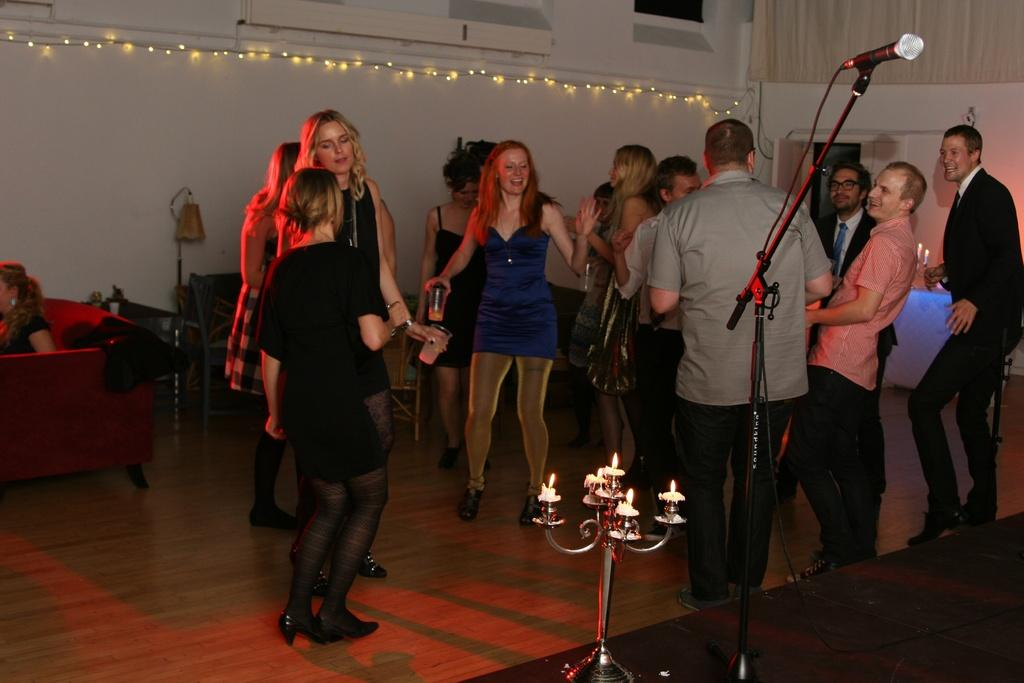What are the people in the room doing? There is a group of people dancing in the room. What can be seen in the room besides the dancing people? There is a microphone stand and a candle stand in the room. What is the girl in the room doing? There is a girl sitting on a sofa in the room. What type of leather is used to make the sofa the girl is sitting on? There is no information about the type of leather used for the sofa, as it is not mentioned in the facts. Additionally, the material of the sofa is not visible in the image. 